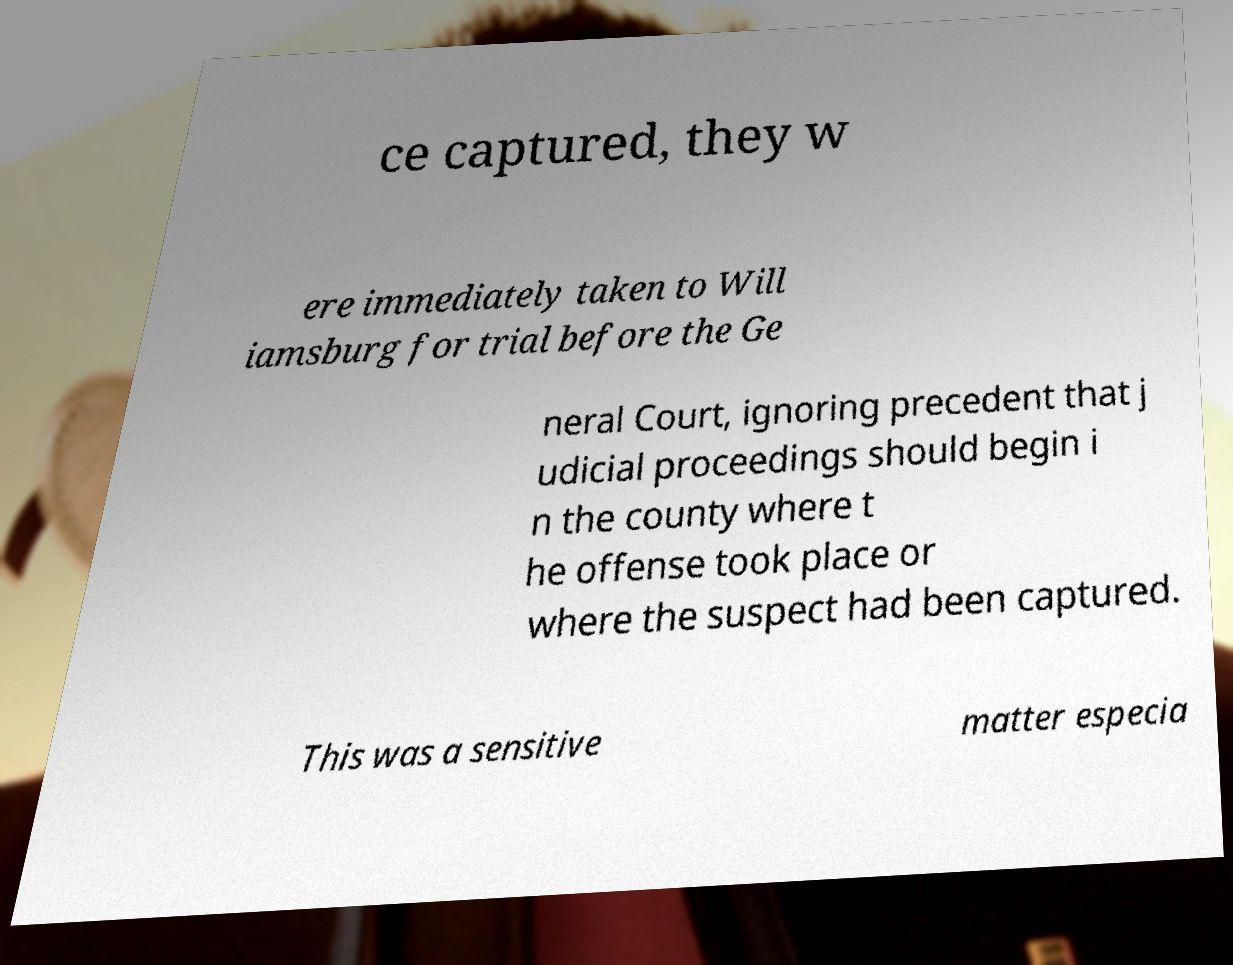Please read and relay the text visible in this image. What does it say? ce captured, they w ere immediately taken to Will iamsburg for trial before the Ge neral Court, ignoring precedent that j udicial proceedings should begin i n the county where t he offense took place or where the suspect had been captured. This was a sensitive matter especia 